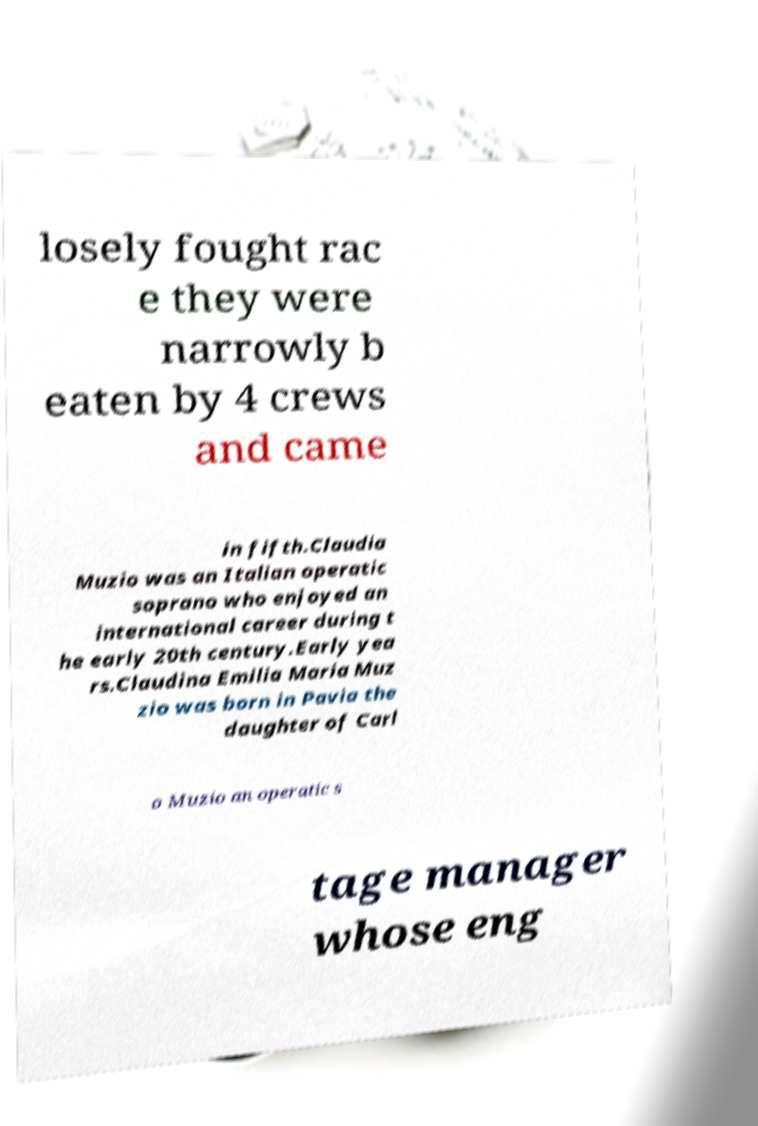For documentation purposes, I need the text within this image transcribed. Could you provide that? losely fought rac e they were narrowly b eaten by 4 crews and came in fifth.Claudia Muzio was an Italian operatic soprano who enjoyed an international career during t he early 20th century.Early yea rs.Claudina Emilia Maria Muz zio was born in Pavia the daughter of Carl o Muzio an operatic s tage manager whose eng 